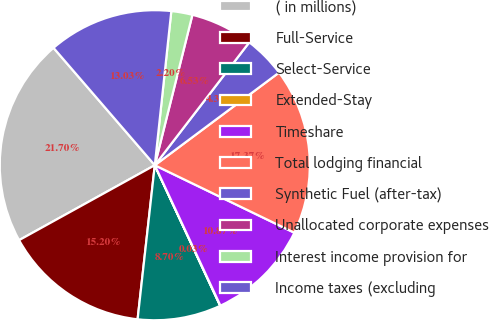Convert chart. <chart><loc_0><loc_0><loc_500><loc_500><pie_chart><fcel>( in millions)<fcel>Full-Service<fcel>Select-Service<fcel>Extended-Stay<fcel>Timeshare<fcel>Total lodging financial<fcel>Synthetic Fuel (after-tax)<fcel>Unallocated corporate expenses<fcel>Interest income provision for<fcel>Income taxes (excluding<nl><fcel>21.7%<fcel>15.2%<fcel>8.7%<fcel>0.03%<fcel>10.87%<fcel>17.37%<fcel>4.37%<fcel>6.53%<fcel>2.2%<fcel>13.03%<nl></chart> 